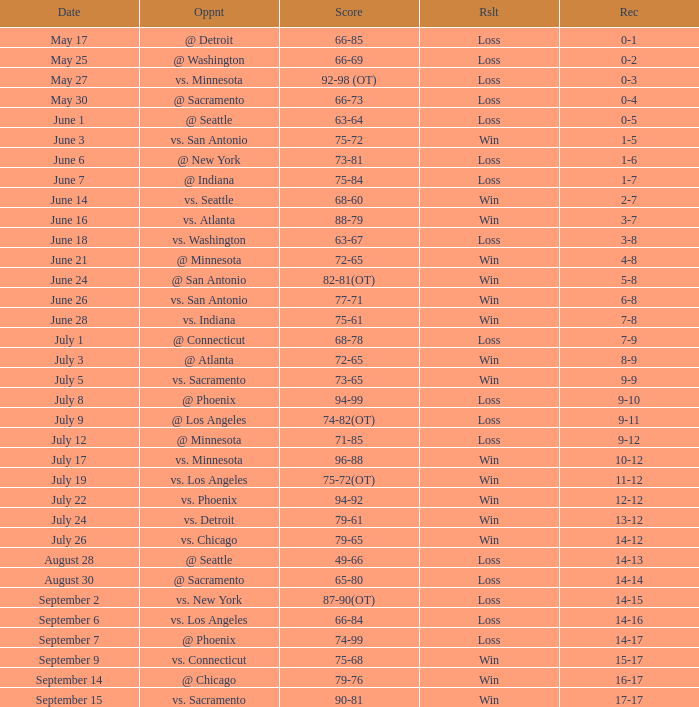What is the Record of the game on June 24? 5-8. 